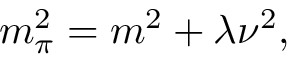<formula> <loc_0><loc_0><loc_500><loc_500>m _ { \pi } ^ { 2 } = m ^ { 2 } + \lambda \nu ^ { 2 } ,</formula> 